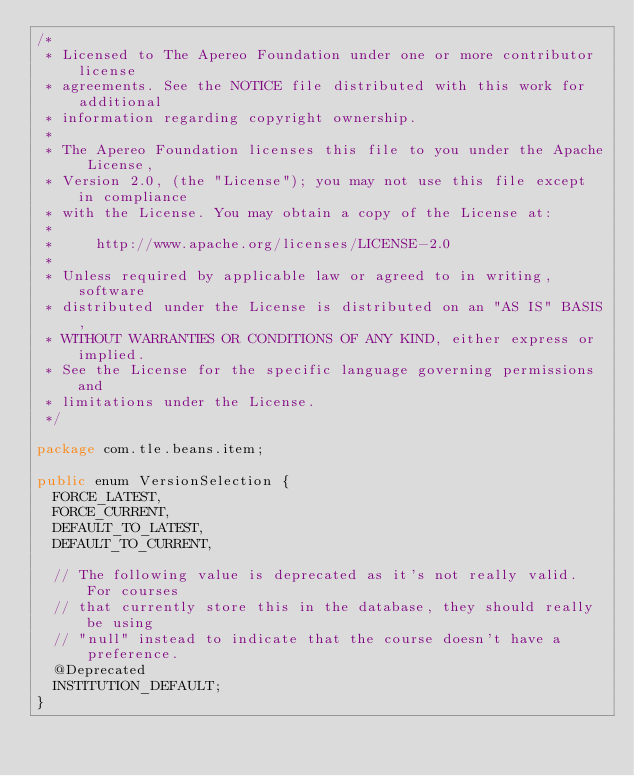<code> <loc_0><loc_0><loc_500><loc_500><_Java_>/*
 * Licensed to The Apereo Foundation under one or more contributor license
 * agreements. See the NOTICE file distributed with this work for additional
 * information regarding copyright ownership.
 *
 * The Apereo Foundation licenses this file to you under the Apache License,
 * Version 2.0, (the "License"); you may not use this file except in compliance
 * with the License. You may obtain a copy of the License at:
 *
 *     http://www.apache.org/licenses/LICENSE-2.0
 *
 * Unless required by applicable law or agreed to in writing, software
 * distributed under the License is distributed on an "AS IS" BASIS,
 * WITHOUT WARRANTIES OR CONDITIONS OF ANY KIND, either express or implied.
 * See the License for the specific language governing permissions and
 * limitations under the License.
 */

package com.tle.beans.item;

public enum VersionSelection {
  FORCE_LATEST,
  FORCE_CURRENT,
  DEFAULT_TO_LATEST,
  DEFAULT_TO_CURRENT,

  // The following value is deprecated as it's not really valid. For courses
  // that currently store this in the database, they should really be using
  // "null" instead to indicate that the course doesn't have a preference.
  @Deprecated
  INSTITUTION_DEFAULT;
}
</code> 